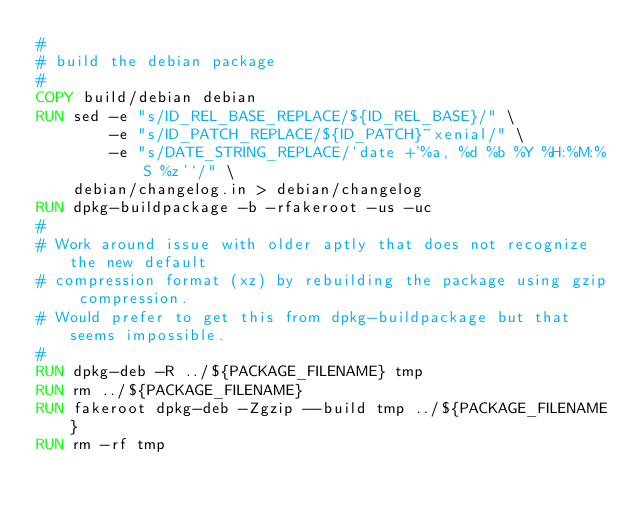<code> <loc_0><loc_0><loc_500><loc_500><_Dockerfile_>#
# build the debian package
#
COPY build/debian debian
RUN sed -e "s/ID_REL_BASE_REPLACE/${ID_REL_BASE}/" \
        -e "s/ID_PATCH_REPLACE/${ID_PATCH}~xenial/" \
        -e "s/DATE_STRING_REPLACE/`date +'%a, %d %b %Y %H:%M:%S %z'`/" \
		debian/changelog.in > debian/changelog
RUN dpkg-buildpackage -b -rfakeroot -us -uc
#
# Work around issue with older aptly that does not recognize the new default
# compression format (xz) by rebuilding the package using gzip compression.
# Would prefer to get this from dpkg-buildpackage but that seems impossible.
#
RUN dpkg-deb -R ../${PACKAGE_FILENAME} tmp
RUN rm ../${PACKAGE_FILENAME}
RUN fakeroot dpkg-deb -Zgzip --build tmp ../${PACKAGE_FILENAME}
RUN rm -rf tmp
</code> 